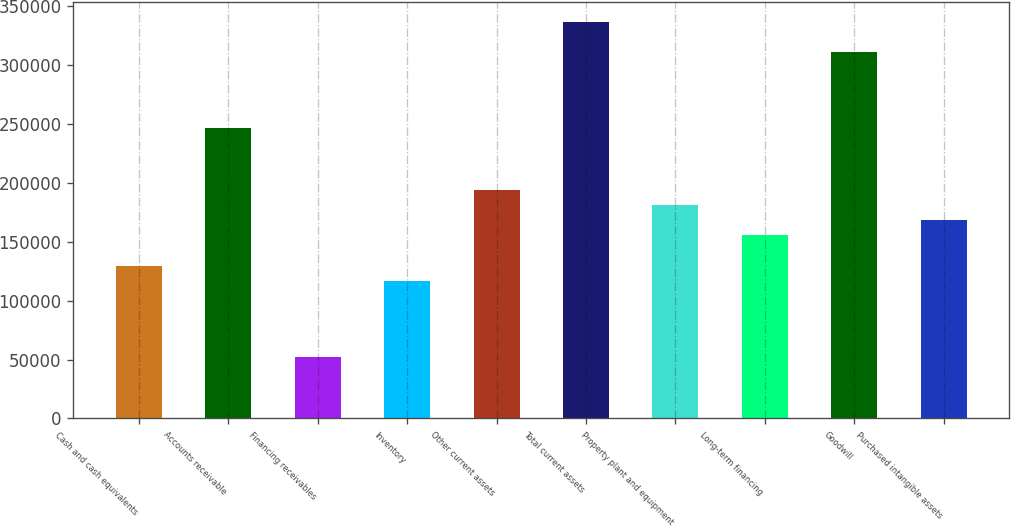Convert chart to OTSL. <chart><loc_0><loc_0><loc_500><loc_500><bar_chart><fcel>Cash and cash equivalents<fcel>Accounts receivable<fcel>Financing receivables<fcel>Inventory<fcel>Other current assets<fcel>Total current assets<fcel>Property plant and equipment<fcel>Long-term financing<fcel>Goodwill<fcel>Purchased intangible assets<nl><fcel>129517<fcel>246064<fcel>51818.8<fcel>116567<fcel>194266<fcel>336712<fcel>181316<fcel>155416<fcel>310813<fcel>168366<nl></chart> 